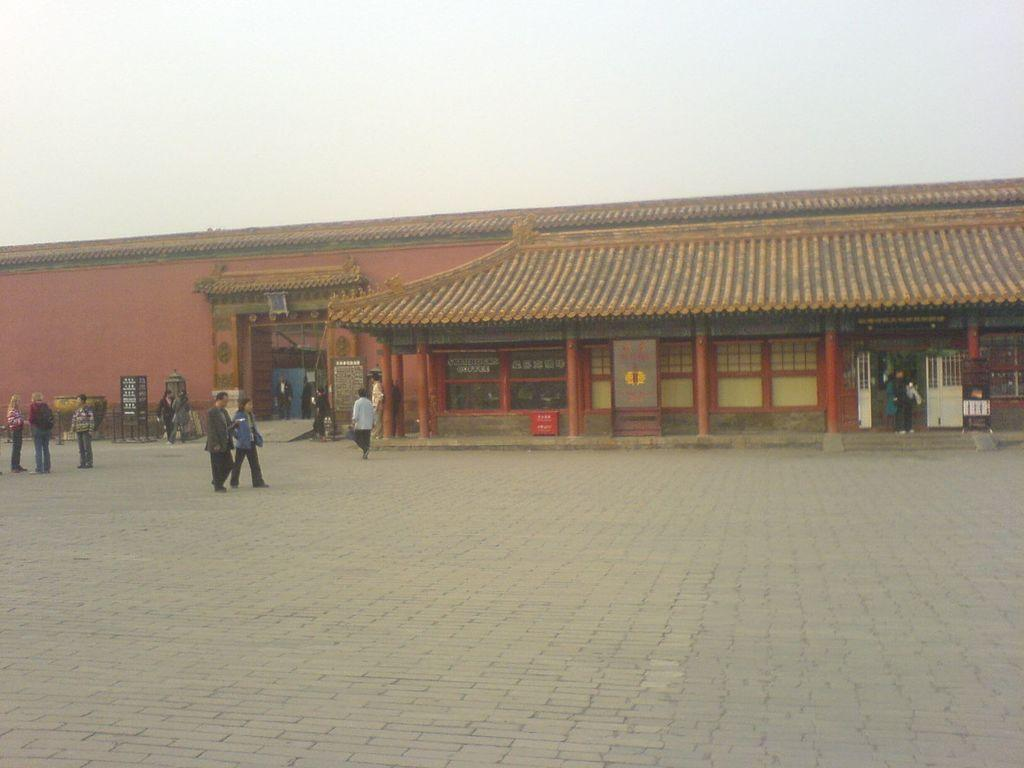How many people can be seen in the image? There are many people in the image. What are the people doing in the image? The people are walking on a road. Can you describe any specific features of the road or its surroundings? There is a place made of red bricks in the image. What type of button can be seen on the vest of the person in the image? There are no people wearing vests or buttons in the image. How many nuts are visible on the ground in the image? There are no nuts visible on the ground in the image. 